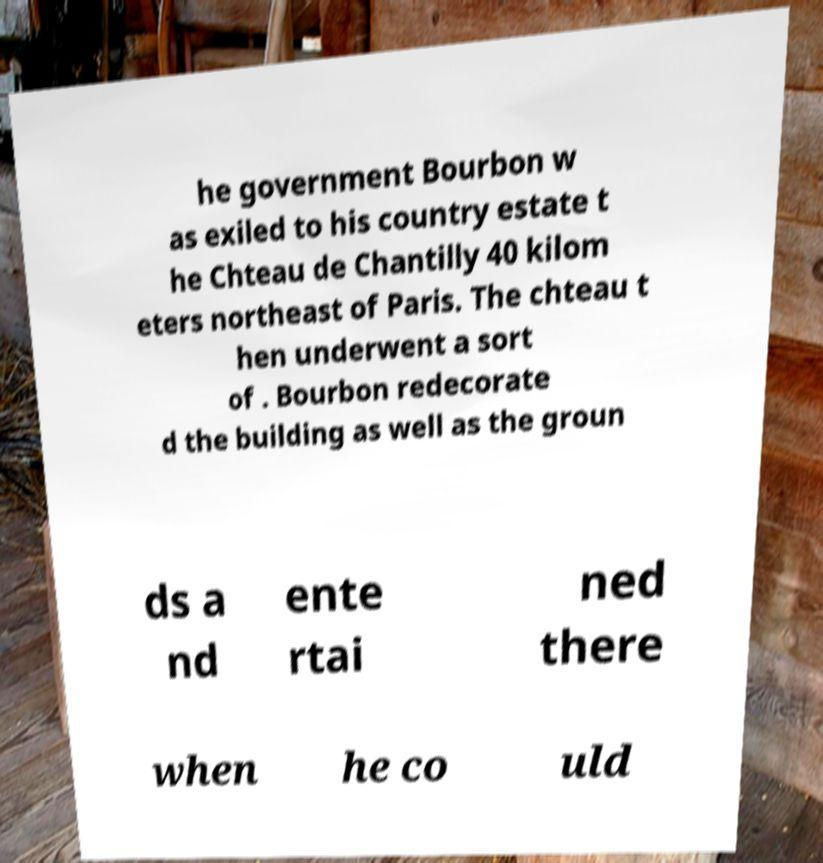Could you assist in decoding the text presented in this image and type it out clearly? he government Bourbon w as exiled to his country estate t he Chteau de Chantilly 40 kilom eters northeast of Paris. The chteau t hen underwent a sort of . Bourbon redecorate d the building as well as the groun ds a nd ente rtai ned there when he co uld 